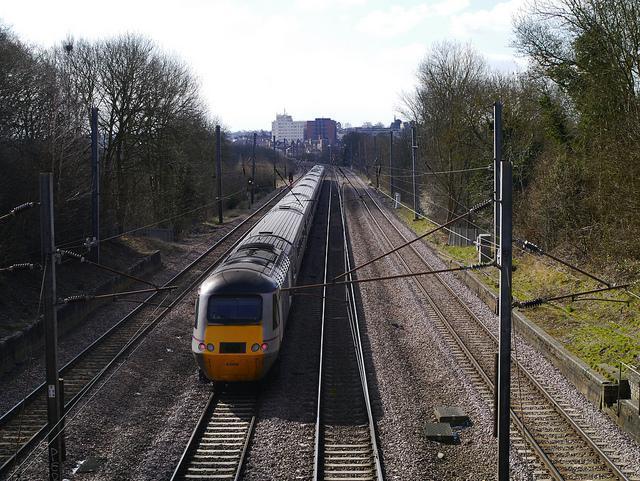How many train tracks are there?
Give a very brief answer. 4. 